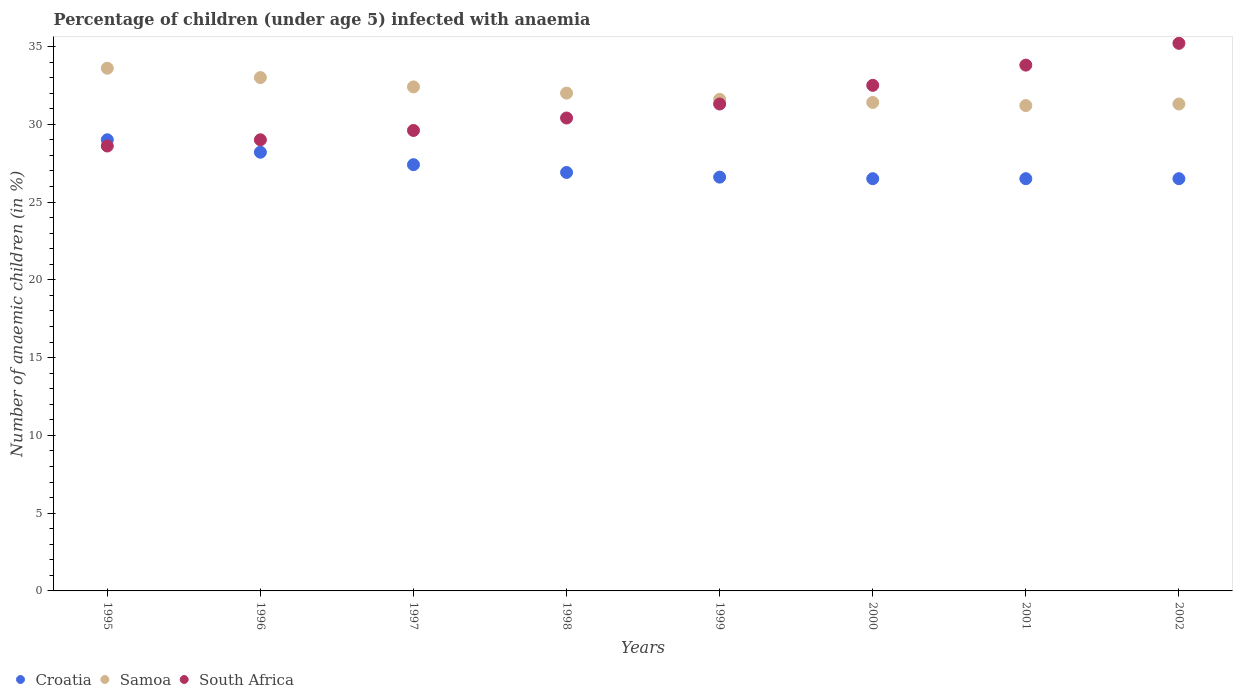How many different coloured dotlines are there?
Provide a short and direct response. 3. What is the percentage of children infected with anaemia in in Samoa in 1999?
Give a very brief answer. 31.6. Across all years, what is the maximum percentage of children infected with anaemia in in Croatia?
Provide a short and direct response. 29. Across all years, what is the minimum percentage of children infected with anaemia in in Samoa?
Give a very brief answer. 31.2. In which year was the percentage of children infected with anaemia in in South Africa minimum?
Provide a succinct answer. 1995. What is the total percentage of children infected with anaemia in in South Africa in the graph?
Offer a terse response. 250.4. What is the difference between the percentage of children infected with anaemia in in Croatia in 1995 and that in 2002?
Offer a very short reply. 2.5. What is the average percentage of children infected with anaemia in in Croatia per year?
Provide a succinct answer. 27.2. In the year 2002, what is the difference between the percentage of children infected with anaemia in in Croatia and percentage of children infected with anaemia in in South Africa?
Your answer should be very brief. -8.7. In how many years, is the percentage of children infected with anaemia in in South Africa greater than 11 %?
Ensure brevity in your answer.  8. What is the ratio of the percentage of children infected with anaemia in in Croatia in 1997 to that in 2000?
Ensure brevity in your answer.  1.03. Is the difference between the percentage of children infected with anaemia in in Croatia in 1996 and 1998 greater than the difference between the percentage of children infected with anaemia in in South Africa in 1996 and 1998?
Your response must be concise. Yes. What is the difference between the highest and the second highest percentage of children infected with anaemia in in South Africa?
Offer a terse response. 1.4. Is it the case that in every year, the sum of the percentage of children infected with anaemia in in Samoa and percentage of children infected with anaemia in in South Africa  is greater than the percentage of children infected with anaemia in in Croatia?
Your answer should be very brief. Yes. Does the percentage of children infected with anaemia in in South Africa monotonically increase over the years?
Your response must be concise. Yes. Is the percentage of children infected with anaemia in in Croatia strictly greater than the percentage of children infected with anaemia in in Samoa over the years?
Provide a succinct answer. No. Is the percentage of children infected with anaemia in in South Africa strictly less than the percentage of children infected with anaemia in in Samoa over the years?
Keep it short and to the point. No. Does the graph contain any zero values?
Provide a succinct answer. No. Does the graph contain grids?
Your response must be concise. No. Where does the legend appear in the graph?
Your answer should be compact. Bottom left. How many legend labels are there?
Keep it short and to the point. 3. How are the legend labels stacked?
Your answer should be very brief. Horizontal. What is the title of the graph?
Provide a short and direct response. Percentage of children (under age 5) infected with anaemia. What is the label or title of the Y-axis?
Offer a very short reply. Number of anaemic children (in %). What is the Number of anaemic children (in %) of Croatia in 1995?
Ensure brevity in your answer.  29. What is the Number of anaemic children (in %) of Samoa in 1995?
Keep it short and to the point. 33.6. What is the Number of anaemic children (in %) in South Africa in 1995?
Give a very brief answer. 28.6. What is the Number of anaemic children (in %) in Croatia in 1996?
Your answer should be very brief. 28.2. What is the Number of anaemic children (in %) in Samoa in 1996?
Offer a very short reply. 33. What is the Number of anaemic children (in %) of South Africa in 1996?
Make the answer very short. 29. What is the Number of anaemic children (in %) of Croatia in 1997?
Provide a succinct answer. 27.4. What is the Number of anaemic children (in %) of Samoa in 1997?
Your response must be concise. 32.4. What is the Number of anaemic children (in %) of South Africa in 1997?
Make the answer very short. 29.6. What is the Number of anaemic children (in %) of Croatia in 1998?
Offer a terse response. 26.9. What is the Number of anaemic children (in %) in South Africa in 1998?
Make the answer very short. 30.4. What is the Number of anaemic children (in %) of Croatia in 1999?
Ensure brevity in your answer.  26.6. What is the Number of anaemic children (in %) in Samoa in 1999?
Your answer should be compact. 31.6. What is the Number of anaemic children (in %) of South Africa in 1999?
Offer a terse response. 31.3. What is the Number of anaemic children (in %) of Samoa in 2000?
Your response must be concise. 31.4. What is the Number of anaemic children (in %) of South Africa in 2000?
Your answer should be compact. 32.5. What is the Number of anaemic children (in %) of Samoa in 2001?
Your response must be concise. 31.2. What is the Number of anaemic children (in %) in South Africa in 2001?
Your answer should be compact. 33.8. What is the Number of anaemic children (in %) in Croatia in 2002?
Provide a succinct answer. 26.5. What is the Number of anaemic children (in %) of Samoa in 2002?
Make the answer very short. 31.3. What is the Number of anaemic children (in %) in South Africa in 2002?
Ensure brevity in your answer.  35.2. Across all years, what is the maximum Number of anaemic children (in %) in Samoa?
Your answer should be compact. 33.6. Across all years, what is the maximum Number of anaemic children (in %) in South Africa?
Offer a very short reply. 35.2. Across all years, what is the minimum Number of anaemic children (in %) of Samoa?
Your response must be concise. 31.2. Across all years, what is the minimum Number of anaemic children (in %) of South Africa?
Provide a short and direct response. 28.6. What is the total Number of anaemic children (in %) of Croatia in the graph?
Your answer should be compact. 217.6. What is the total Number of anaemic children (in %) of Samoa in the graph?
Give a very brief answer. 256.5. What is the total Number of anaemic children (in %) in South Africa in the graph?
Provide a succinct answer. 250.4. What is the difference between the Number of anaemic children (in %) in Croatia in 1995 and that in 1998?
Provide a short and direct response. 2.1. What is the difference between the Number of anaemic children (in %) in Samoa in 1995 and that in 1998?
Offer a terse response. 1.6. What is the difference between the Number of anaemic children (in %) in Croatia in 1995 and that in 1999?
Offer a terse response. 2.4. What is the difference between the Number of anaemic children (in %) in Samoa in 1995 and that in 1999?
Give a very brief answer. 2. What is the difference between the Number of anaemic children (in %) in South Africa in 1995 and that in 1999?
Provide a succinct answer. -2.7. What is the difference between the Number of anaemic children (in %) in South Africa in 1995 and that in 2001?
Offer a terse response. -5.2. What is the difference between the Number of anaemic children (in %) in Croatia in 1995 and that in 2002?
Offer a terse response. 2.5. What is the difference between the Number of anaemic children (in %) in Samoa in 1995 and that in 2002?
Your response must be concise. 2.3. What is the difference between the Number of anaemic children (in %) of South Africa in 1996 and that in 1997?
Offer a very short reply. -0.6. What is the difference between the Number of anaemic children (in %) in Croatia in 1996 and that in 1998?
Give a very brief answer. 1.3. What is the difference between the Number of anaemic children (in %) in South Africa in 1996 and that in 1999?
Make the answer very short. -2.3. What is the difference between the Number of anaemic children (in %) of Samoa in 1996 and that in 2000?
Provide a short and direct response. 1.6. What is the difference between the Number of anaemic children (in %) of Samoa in 1996 and that in 2001?
Make the answer very short. 1.8. What is the difference between the Number of anaemic children (in %) in South Africa in 1996 and that in 2002?
Your answer should be very brief. -6.2. What is the difference between the Number of anaemic children (in %) in Samoa in 1997 and that in 1998?
Offer a terse response. 0.4. What is the difference between the Number of anaemic children (in %) of South Africa in 1997 and that in 1998?
Offer a very short reply. -0.8. What is the difference between the Number of anaemic children (in %) in South Africa in 1997 and that in 2000?
Your answer should be compact. -2.9. What is the difference between the Number of anaemic children (in %) of Croatia in 1997 and that in 2001?
Ensure brevity in your answer.  0.9. What is the difference between the Number of anaemic children (in %) of Samoa in 1997 and that in 2001?
Provide a succinct answer. 1.2. What is the difference between the Number of anaemic children (in %) in South Africa in 1997 and that in 2001?
Provide a short and direct response. -4.2. What is the difference between the Number of anaemic children (in %) of Samoa in 1997 and that in 2002?
Ensure brevity in your answer.  1.1. What is the difference between the Number of anaemic children (in %) in South Africa in 1997 and that in 2002?
Your response must be concise. -5.6. What is the difference between the Number of anaemic children (in %) of Samoa in 1998 and that in 1999?
Make the answer very short. 0.4. What is the difference between the Number of anaemic children (in %) of Croatia in 1998 and that in 2000?
Keep it short and to the point. 0.4. What is the difference between the Number of anaemic children (in %) in South Africa in 1998 and that in 2000?
Give a very brief answer. -2.1. What is the difference between the Number of anaemic children (in %) in Croatia in 1998 and that in 2001?
Make the answer very short. 0.4. What is the difference between the Number of anaemic children (in %) in South Africa in 1998 and that in 2001?
Your answer should be very brief. -3.4. What is the difference between the Number of anaemic children (in %) of Samoa in 1998 and that in 2002?
Offer a terse response. 0.7. What is the difference between the Number of anaemic children (in %) in South Africa in 1998 and that in 2002?
Keep it short and to the point. -4.8. What is the difference between the Number of anaemic children (in %) in South Africa in 1999 and that in 2001?
Give a very brief answer. -2.5. What is the difference between the Number of anaemic children (in %) of Croatia in 2000 and that in 2001?
Your response must be concise. 0. What is the difference between the Number of anaemic children (in %) in South Africa in 2000 and that in 2001?
Your answer should be compact. -1.3. What is the difference between the Number of anaemic children (in %) in Samoa in 2000 and that in 2002?
Your answer should be compact. 0.1. What is the difference between the Number of anaemic children (in %) in South Africa in 2000 and that in 2002?
Offer a very short reply. -2.7. What is the difference between the Number of anaemic children (in %) of Croatia in 2001 and that in 2002?
Ensure brevity in your answer.  0. What is the difference between the Number of anaemic children (in %) in South Africa in 2001 and that in 2002?
Keep it short and to the point. -1.4. What is the difference between the Number of anaemic children (in %) in Croatia in 1995 and the Number of anaemic children (in %) in South Africa in 1996?
Give a very brief answer. 0. What is the difference between the Number of anaemic children (in %) in Samoa in 1995 and the Number of anaemic children (in %) in South Africa in 1996?
Ensure brevity in your answer.  4.6. What is the difference between the Number of anaemic children (in %) of Croatia in 1995 and the Number of anaemic children (in %) of Samoa in 1997?
Ensure brevity in your answer.  -3.4. What is the difference between the Number of anaemic children (in %) of Croatia in 1995 and the Number of anaemic children (in %) of Samoa in 1999?
Ensure brevity in your answer.  -2.6. What is the difference between the Number of anaemic children (in %) of Samoa in 1995 and the Number of anaemic children (in %) of South Africa in 1999?
Your answer should be very brief. 2.3. What is the difference between the Number of anaemic children (in %) of Croatia in 1995 and the Number of anaemic children (in %) of Samoa in 2000?
Provide a short and direct response. -2.4. What is the difference between the Number of anaemic children (in %) of Croatia in 1995 and the Number of anaemic children (in %) of South Africa in 2001?
Your response must be concise. -4.8. What is the difference between the Number of anaemic children (in %) in Croatia in 1995 and the Number of anaemic children (in %) in South Africa in 2002?
Provide a short and direct response. -6.2. What is the difference between the Number of anaemic children (in %) in Croatia in 1996 and the Number of anaemic children (in %) in Samoa in 1997?
Give a very brief answer. -4.2. What is the difference between the Number of anaemic children (in %) of Samoa in 1996 and the Number of anaemic children (in %) of South Africa in 1997?
Give a very brief answer. 3.4. What is the difference between the Number of anaemic children (in %) of Samoa in 1996 and the Number of anaemic children (in %) of South Africa in 1998?
Ensure brevity in your answer.  2.6. What is the difference between the Number of anaemic children (in %) of Croatia in 1996 and the Number of anaemic children (in %) of South Africa in 1999?
Offer a very short reply. -3.1. What is the difference between the Number of anaemic children (in %) in Samoa in 1996 and the Number of anaemic children (in %) in South Africa in 1999?
Provide a short and direct response. 1.7. What is the difference between the Number of anaemic children (in %) of Samoa in 1996 and the Number of anaemic children (in %) of South Africa in 2000?
Your response must be concise. 0.5. What is the difference between the Number of anaemic children (in %) of Croatia in 1996 and the Number of anaemic children (in %) of South Africa in 2001?
Ensure brevity in your answer.  -5.6. What is the difference between the Number of anaemic children (in %) of Samoa in 1996 and the Number of anaemic children (in %) of South Africa in 2001?
Give a very brief answer. -0.8. What is the difference between the Number of anaemic children (in %) of Croatia in 1997 and the Number of anaemic children (in %) of South Africa in 1998?
Offer a terse response. -3. What is the difference between the Number of anaemic children (in %) of Croatia in 1997 and the Number of anaemic children (in %) of South Africa in 1999?
Provide a short and direct response. -3.9. What is the difference between the Number of anaemic children (in %) in Croatia in 1997 and the Number of anaemic children (in %) in South Africa in 2000?
Ensure brevity in your answer.  -5.1. What is the difference between the Number of anaemic children (in %) of Croatia in 1997 and the Number of anaemic children (in %) of South Africa in 2001?
Offer a very short reply. -6.4. What is the difference between the Number of anaemic children (in %) of Samoa in 1997 and the Number of anaemic children (in %) of South Africa in 2001?
Offer a terse response. -1.4. What is the difference between the Number of anaemic children (in %) in Croatia in 1997 and the Number of anaemic children (in %) in Samoa in 2002?
Keep it short and to the point. -3.9. What is the difference between the Number of anaemic children (in %) in Croatia in 1998 and the Number of anaemic children (in %) in Samoa in 1999?
Your answer should be very brief. -4.7. What is the difference between the Number of anaemic children (in %) of Croatia in 1998 and the Number of anaemic children (in %) of South Africa in 1999?
Keep it short and to the point. -4.4. What is the difference between the Number of anaemic children (in %) of Croatia in 1998 and the Number of anaemic children (in %) of Samoa in 2000?
Ensure brevity in your answer.  -4.5. What is the difference between the Number of anaemic children (in %) of Croatia in 1998 and the Number of anaemic children (in %) of Samoa in 2001?
Your answer should be compact. -4.3. What is the difference between the Number of anaemic children (in %) in Croatia in 1998 and the Number of anaemic children (in %) in Samoa in 2002?
Your response must be concise. -4.4. What is the difference between the Number of anaemic children (in %) in Samoa in 1998 and the Number of anaemic children (in %) in South Africa in 2002?
Give a very brief answer. -3.2. What is the difference between the Number of anaemic children (in %) in Croatia in 1999 and the Number of anaemic children (in %) in Samoa in 2000?
Your response must be concise. -4.8. What is the difference between the Number of anaemic children (in %) of Samoa in 1999 and the Number of anaemic children (in %) of South Africa in 2000?
Offer a terse response. -0.9. What is the difference between the Number of anaemic children (in %) in Croatia in 1999 and the Number of anaemic children (in %) in South Africa in 2001?
Make the answer very short. -7.2. What is the difference between the Number of anaemic children (in %) in Samoa in 1999 and the Number of anaemic children (in %) in South Africa in 2002?
Your response must be concise. -3.6. What is the difference between the Number of anaemic children (in %) of Croatia in 2000 and the Number of anaemic children (in %) of South Africa in 2001?
Provide a short and direct response. -7.3. What is the difference between the Number of anaemic children (in %) of Croatia in 2000 and the Number of anaemic children (in %) of Samoa in 2002?
Provide a short and direct response. -4.8. What is the difference between the Number of anaemic children (in %) in Croatia in 2000 and the Number of anaemic children (in %) in South Africa in 2002?
Give a very brief answer. -8.7. What is the difference between the Number of anaemic children (in %) of Croatia in 2001 and the Number of anaemic children (in %) of South Africa in 2002?
Provide a short and direct response. -8.7. What is the average Number of anaemic children (in %) of Croatia per year?
Your response must be concise. 27.2. What is the average Number of anaemic children (in %) of Samoa per year?
Make the answer very short. 32.06. What is the average Number of anaemic children (in %) in South Africa per year?
Keep it short and to the point. 31.3. In the year 1995, what is the difference between the Number of anaemic children (in %) in Croatia and Number of anaemic children (in %) in Samoa?
Offer a very short reply. -4.6. In the year 1996, what is the difference between the Number of anaemic children (in %) in Croatia and Number of anaemic children (in %) in Samoa?
Your answer should be very brief. -4.8. In the year 1996, what is the difference between the Number of anaemic children (in %) in Croatia and Number of anaemic children (in %) in South Africa?
Your answer should be very brief. -0.8. In the year 1997, what is the difference between the Number of anaemic children (in %) of Croatia and Number of anaemic children (in %) of Samoa?
Ensure brevity in your answer.  -5. In the year 2000, what is the difference between the Number of anaemic children (in %) in Croatia and Number of anaemic children (in %) in South Africa?
Your answer should be very brief. -6. In the year 2000, what is the difference between the Number of anaemic children (in %) of Samoa and Number of anaemic children (in %) of South Africa?
Offer a terse response. -1.1. In the year 2001, what is the difference between the Number of anaemic children (in %) of Croatia and Number of anaemic children (in %) of Samoa?
Provide a short and direct response. -4.7. In the year 2001, what is the difference between the Number of anaemic children (in %) of Croatia and Number of anaemic children (in %) of South Africa?
Your answer should be compact. -7.3. In the year 2002, what is the difference between the Number of anaemic children (in %) in Croatia and Number of anaemic children (in %) in Samoa?
Make the answer very short. -4.8. In the year 2002, what is the difference between the Number of anaemic children (in %) in Croatia and Number of anaemic children (in %) in South Africa?
Ensure brevity in your answer.  -8.7. In the year 2002, what is the difference between the Number of anaemic children (in %) in Samoa and Number of anaemic children (in %) in South Africa?
Offer a very short reply. -3.9. What is the ratio of the Number of anaemic children (in %) in Croatia in 1995 to that in 1996?
Give a very brief answer. 1.03. What is the ratio of the Number of anaemic children (in %) in Samoa in 1995 to that in 1996?
Your answer should be compact. 1.02. What is the ratio of the Number of anaemic children (in %) in South Africa in 1995 to that in 1996?
Your answer should be very brief. 0.99. What is the ratio of the Number of anaemic children (in %) of Croatia in 1995 to that in 1997?
Offer a terse response. 1.06. What is the ratio of the Number of anaemic children (in %) in South Africa in 1995 to that in 1997?
Your answer should be very brief. 0.97. What is the ratio of the Number of anaemic children (in %) of Croatia in 1995 to that in 1998?
Keep it short and to the point. 1.08. What is the ratio of the Number of anaemic children (in %) in Samoa in 1995 to that in 1998?
Give a very brief answer. 1.05. What is the ratio of the Number of anaemic children (in %) of South Africa in 1995 to that in 1998?
Provide a short and direct response. 0.94. What is the ratio of the Number of anaemic children (in %) in Croatia in 1995 to that in 1999?
Your answer should be very brief. 1.09. What is the ratio of the Number of anaemic children (in %) of Samoa in 1995 to that in 1999?
Your answer should be very brief. 1.06. What is the ratio of the Number of anaemic children (in %) of South Africa in 1995 to that in 1999?
Offer a very short reply. 0.91. What is the ratio of the Number of anaemic children (in %) in Croatia in 1995 to that in 2000?
Make the answer very short. 1.09. What is the ratio of the Number of anaemic children (in %) of Samoa in 1995 to that in 2000?
Keep it short and to the point. 1.07. What is the ratio of the Number of anaemic children (in %) of South Africa in 1995 to that in 2000?
Offer a terse response. 0.88. What is the ratio of the Number of anaemic children (in %) in Croatia in 1995 to that in 2001?
Provide a short and direct response. 1.09. What is the ratio of the Number of anaemic children (in %) in Samoa in 1995 to that in 2001?
Give a very brief answer. 1.08. What is the ratio of the Number of anaemic children (in %) of South Africa in 1995 to that in 2001?
Keep it short and to the point. 0.85. What is the ratio of the Number of anaemic children (in %) in Croatia in 1995 to that in 2002?
Your answer should be compact. 1.09. What is the ratio of the Number of anaemic children (in %) of Samoa in 1995 to that in 2002?
Ensure brevity in your answer.  1.07. What is the ratio of the Number of anaemic children (in %) in South Africa in 1995 to that in 2002?
Ensure brevity in your answer.  0.81. What is the ratio of the Number of anaemic children (in %) in Croatia in 1996 to that in 1997?
Offer a terse response. 1.03. What is the ratio of the Number of anaemic children (in %) of Samoa in 1996 to that in 1997?
Your answer should be compact. 1.02. What is the ratio of the Number of anaemic children (in %) of South Africa in 1996 to that in 1997?
Make the answer very short. 0.98. What is the ratio of the Number of anaemic children (in %) in Croatia in 1996 to that in 1998?
Offer a very short reply. 1.05. What is the ratio of the Number of anaemic children (in %) in Samoa in 1996 to that in 1998?
Keep it short and to the point. 1.03. What is the ratio of the Number of anaemic children (in %) in South Africa in 1996 to that in 1998?
Keep it short and to the point. 0.95. What is the ratio of the Number of anaemic children (in %) in Croatia in 1996 to that in 1999?
Keep it short and to the point. 1.06. What is the ratio of the Number of anaemic children (in %) in Samoa in 1996 to that in 1999?
Offer a very short reply. 1.04. What is the ratio of the Number of anaemic children (in %) of South Africa in 1996 to that in 1999?
Offer a terse response. 0.93. What is the ratio of the Number of anaemic children (in %) of Croatia in 1996 to that in 2000?
Your answer should be very brief. 1.06. What is the ratio of the Number of anaemic children (in %) in Samoa in 1996 to that in 2000?
Offer a terse response. 1.05. What is the ratio of the Number of anaemic children (in %) of South Africa in 1996 to that in 2000?
Make the answer very short. 0.89. What is the ratio of the Number of anaemic children (in %) of Croatia in 1996 to that in 2001?
Make the answer very short. 1.06. What is the ratio of the Number of anaemic children (in %) of Samoa in 1996 to that in 2001?
Your answer should be compact. 1.06. What is the ratio of the Number of anaemic children (in %) in South Africa in 1996 to that in 2001?
Keep it short and to the point. 0.86. What is the ratio of the Number of anaemic children (in %) of Croatia in 1996 to that in 2002?
Offer a very short reply. 1.06. What is the ratio of the Number of anaemic children (in %) in Samoa in 1996 to that in 2002?
Offer a terse response. 1.05. What is the ratio of the Number of anaemic children (in %) of South Africa in 1996 to that in 2002?
Give a very brief answer. 0.82. What is the ratio of the Number of anaemic children (in %) in Croatia in 1997 to that in 1998?
Offer a terse response. 1.02. What is the ratio of the Number of anaemic children (in %) of Samoa in 1997 to that in 1998?
Provide a succinct answer. 1.01. What is the ratio of the Number of anaemic children (in %) of South Africa in 1997 to that in 1998?
Ensure brevity in your answer.  0.97. What is the ratio of the Number of anaemic children (in %) of Croatia in 1997 to that in 1999?
Your response must be concise. 1.03. What is the ratio of the Number of anaemic children (in %) in Samoa in 1997 to that in 1999?
Give a very brief answer. 1.03. What is the ratio of the Number of anaemic children (in %) of South Africa in 1997 to that in 1999?
Offer a very short reply. 0.95. What is the ratio of the Number of anaemic children (in %) in Croatia in 1997 to that in 2000?
Offer a terse response. 1.03. What is the ratio of the Number of anaemic children (in %) in Samoa in 1997 to that in 2000?
Give a very brief answer. 1.03. What is the ratio of the Number of anaemic children (in %) of South Africa in 1997 to that in 2000?
Keep it short and to the point. 0.91. What is the ratio of the Number of anaemic children (in %) of Croatia in 1997 to that in 2001?
Keep it short and to the point. 1.03. What is the ratio of the Number of anaemic children (in %) of South Africa in 1997 to that in 2001?
Keep it short and to the point. 0.88. What is the ratio of the Number of anaemic children (in %) in Croatia in 1997 to that in 2002?
Make the answer very short. 1.03. What is the ratio of the Number of anaemic children (in %) of Samoa in 1997 to that in 2002?
Give a very brief answer. 1.04. What is the ratio of the Number of anaemic children (in %) of South Africa in 1997 to that in 2002?
Your answer should be compact. 0.84. What is the ratio of the Number of anaemic children (in %) in Croatia in 1998 to that in 1999?
Your answer should be very brief. 1.01. What is the ratio of the Number of anaemic children (in %) in Samoa in 1998 to that in 1999?
Make the answer very short. 1.01. What is the ratio of the Number of anaemic children (in %) in South Africa in 1998 to that in 1999?
Your answer should be compact. 0.97. What is the ratio of the Number of anaemic children (in %) of Croatia in 1998 to that in 2000?
Make the answer very short. 1.02. What is the ratio of the Number of anaemic children (in %) of Samoa in 1998 to that in 2000?
Your response must be concise. 1.02. What is the ratio of the Number of anaemic children (in %) in South Africa in 1998 to that in 2000?
Keep it short and to the point. 0.94. What is the ratio of the Number of anaemic children (in %) of Croatia in 1998 to that in 2001?
Offer a very short reply. 1.02. What is the ratio of the Number of anaemic children (in %) in Samoa in 1998 to that in 2001?
Ensure brevity in your answer.  1.03. What is the ratio of the Number of anaemic children (in %) in South Africa in 1998 to that in 2001?
Provide a succinct answer. 0.9. What is the ratio of the Number of anaemic children (in %) of Croatia in 1998 to that in 2002?
Offer a very short reply. 1.02. What is the ratio of the Number of anaemic children (in %) in Samoa in 1998 to that in 2002?
Offer a terse response. 1.02. What is the ratio of the Number of anaemic children (in %) in South Africa in 1998 to that in 2002?
Offer a very short reply. 0.86. What is the ratio of the Number of anaemic children (in %) in Samoa in 1999 to that in 2000?
Your answer should be very brief. 1.01. What is the ratio of the Number of anaemic children (in %) of South Africa in 1999 to that in 2000?
Make the answer very short. 0.96. What is the ratio of the Number of anaemic children (in %) in Croatia in 1999 to that in 2001?
Offer a very short reply. 1. What is the ratio of the Number of anaemic children (in %) in Samoa in 1999 to that in 2001?
Offer a very short reply. 1.01. What is the ratio of the Number of anaemic children (in %) in South Africa in 1999 to that in 2001?
Provide a succinct answer. 0.93. What is the ratio of the Number of anaemic children (in %) in Samoa in 1999 to that in 2002?
Ensure brevity in your answer.  1.01. What is the ratio of the Number of anaemic children (in %) of South Africa in 1999 to that in 2002?
Make the answer very short. 0.89. What is the ratio of the Number of anaemic children (in %) in Croatia in 2000 to that in 2001?
Your response must be concise. 1. What is the ratio of the Number of anaemic children (in %) of Samoa in 2000 to that in 2001?
Keep it short and to the point. 1.01. What is the ratio of the Number of anaemic children (in %) in South Africa in 2000 to that in 2001?
Give a very brief answer. 0.96. What is the ratio of the Number of anaemic children (in %) of Croatia in 2000 to that in 2002?
Provide a short and direct response. 1. What is the ratio of the Number of anaemic children (in %) of Samoa in 2000 to that in 2002?
Offer a very short reply. 1. What is the ratio of the Number of anaemic children (in %) of South Africa in 2000 to that in 2002?
Ensure brevity in your answer.  0.92. What is the ratio of the Number of anaemic children (in %) of Samoa in 2001 to that in 2002?
Keep it short and to the point. 1. What is the ratio of the Number of anaemic children (in %) of South Africa in 2001 to that in 2002?
Offer a terse response. 0.96. What is the difference between the highest and the second highest Number of anaemic children (in %) in Samoa?
Offer a very short reply. 0.6. What is the difference between the highest and the lowest Number of anaemic children (in %) of Croatia?
Your answer should be compact. 2.5. 